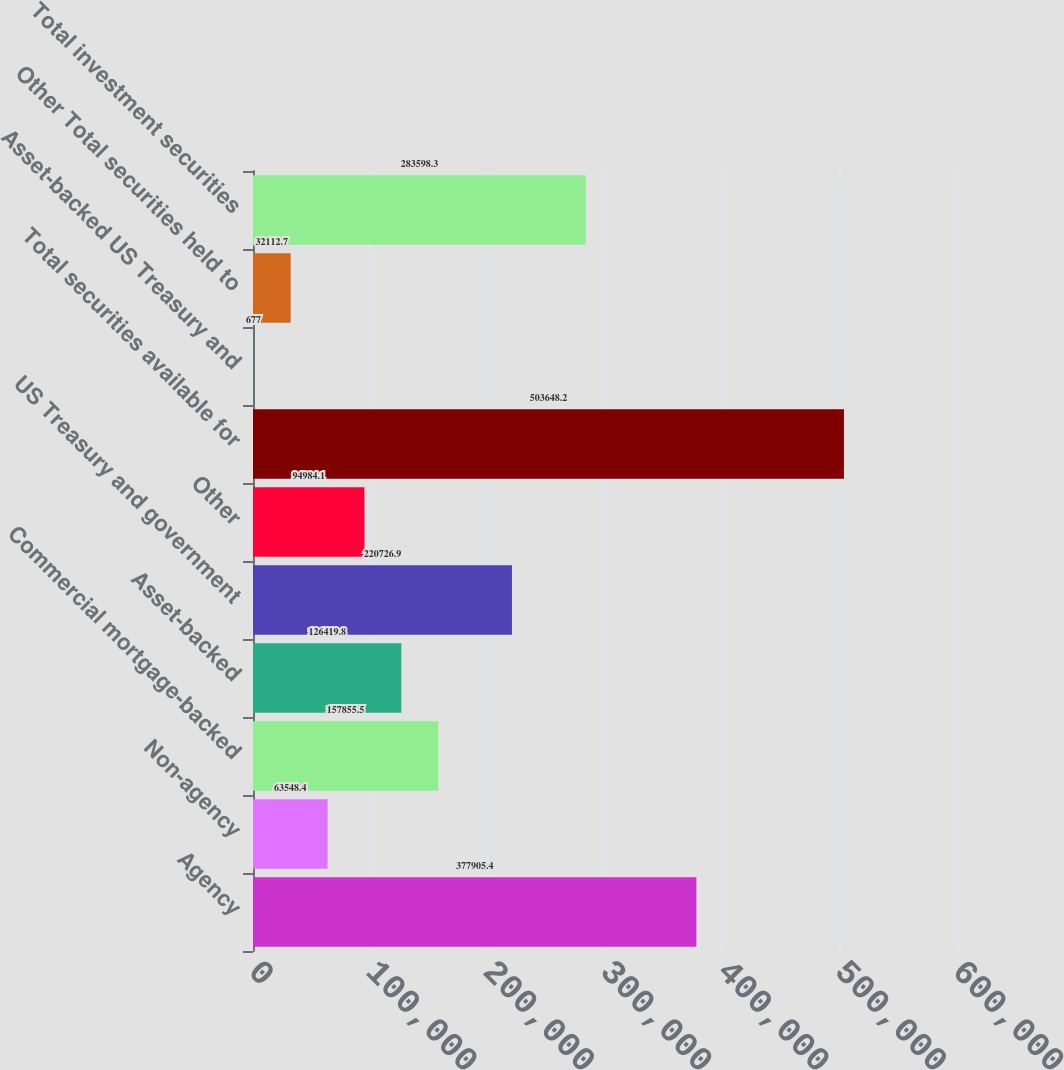Convert chart to OTSL. <chart><loc_0><loc_0><loc_500><loc_500><bar_chart><fcel>Agency<fcel>Non-agency<fcel>Commercial mortgage-backed<fcel>Asset-backed<fcel>US Treasury and government<fcel>Other<fcel>Total securities available for<fcel>Asset-backed US Treasury and<fcel>Other Total securities held to<fcel>Total investment securities<nl><fcel>377905<fcel>63548.4<fcel>157856<fcel>126420<fcel>220727<fcel>94984.1<fcel>503648<fcel>677<fcel>32112.7<fcel>283598<nl></chart> 